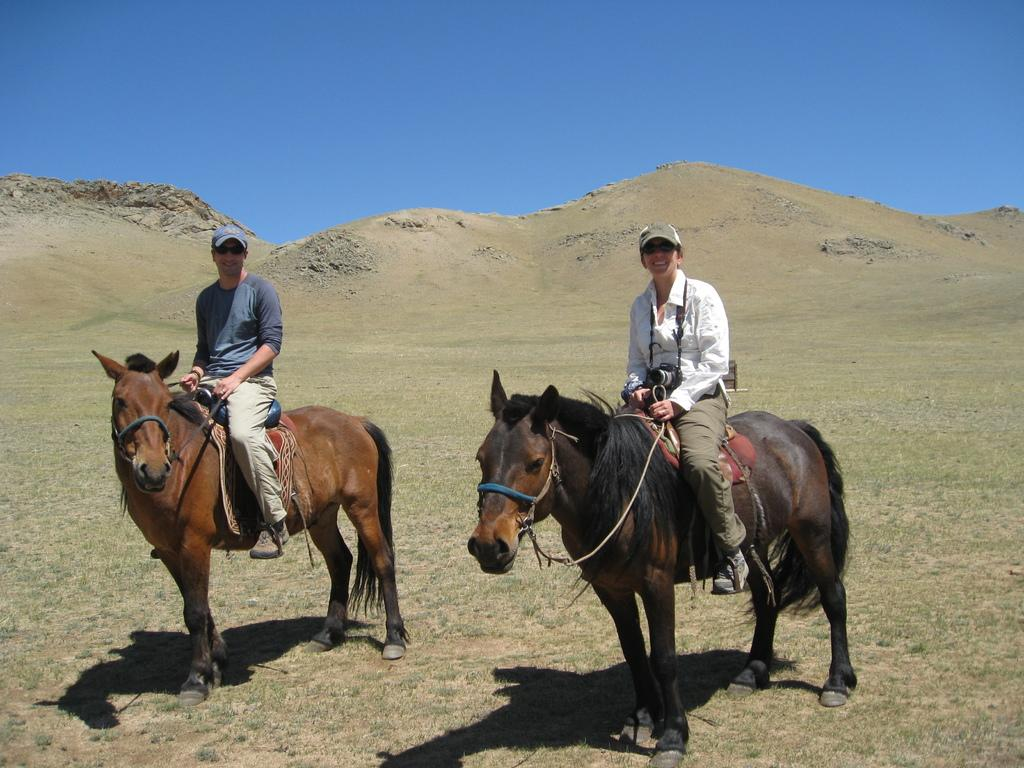How many people are in the image? There are 2 people in the image. What are the people doing in the image? The people are riding horses. Are there any other people in the image besides the ones riding horses? Yes, there are people holding cameras in the image. What can be seen in the background of the image? There is a hill visible in the image, and the sky is also visible. What is the rate of pleasure experienced by the cows in the image? There are no cows present in the image, so it is not possible to determine their rate of pleasure. 